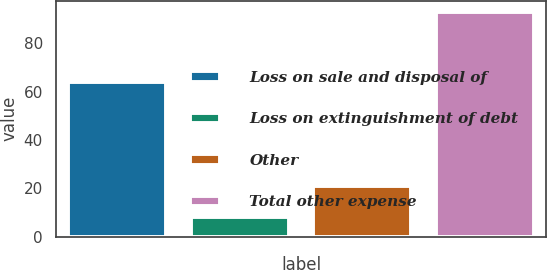Convert chart to OTSL. <chart><loc_0><loc_0><loc_500><loc_500><bar_chart><fcel>Loss on sale and disposal of<fcel>Loss on extinguishment of debt<fcel>Other<fcel>Total other expense<nl><fcel>64<fcel>8<fcel>21<fcel>93<nl></chart> 